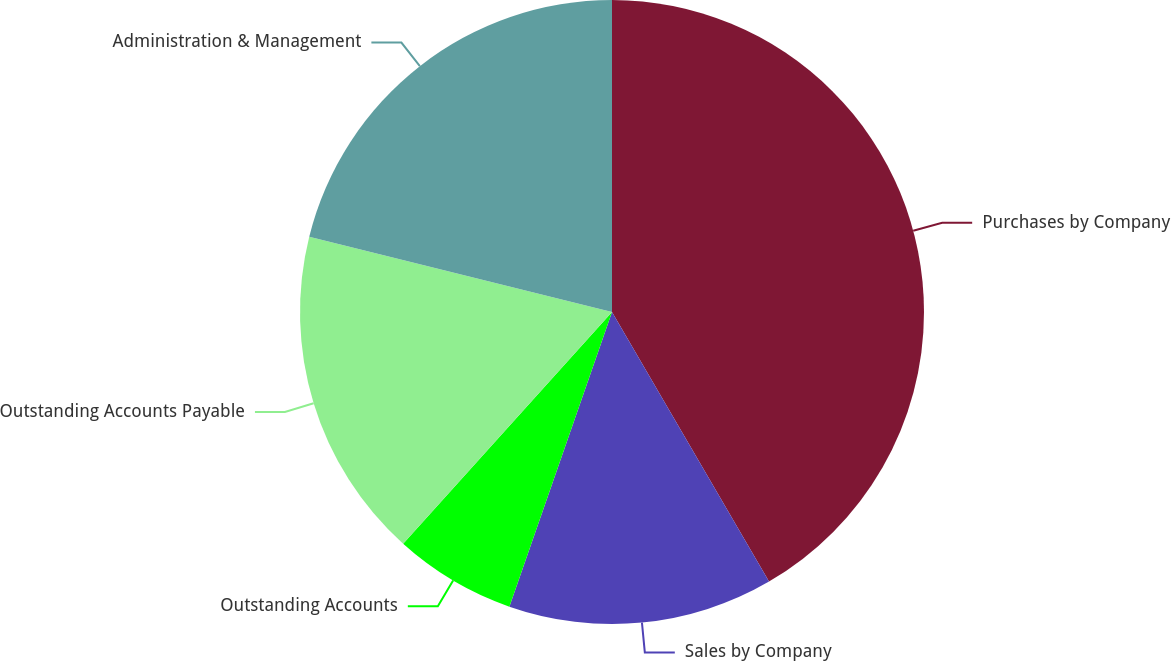Convert chart. <chart><loc_0><loc_0><loc_500><loc_500><pie_chart><fcel>Purchases by Company<fcel>Sales by Company<fcel>Outstanding Accounts<fcel>Outstanding Accounts Payable<fcel>Administration & Management<nl><fcel>41.61%<fcel>13.73%<fcel>6.34%<fcel>17.21%<fcel>21.12%<nl></chart> 